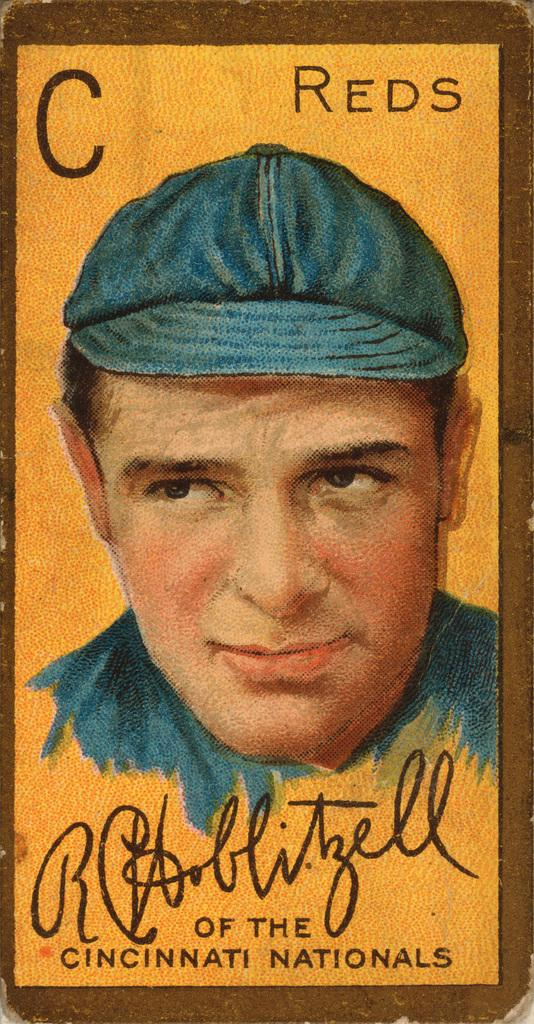What is the main object in the image? There is a poster in the image. What is depicted in the middle of the poster? In the middle of the poster, there is a man. What is the man wearing on his head? The man is wearing a cap. What is the man wearing on his upper body? The man is wearing a shirt. Where can text be found on the poster? Text can be found at the top and bottom of the poster. What type of powder is being used to grow the cabbage in the image? There is no cabbage or powder present in the image; it features a poster with a man wearing a cap and shirt. 